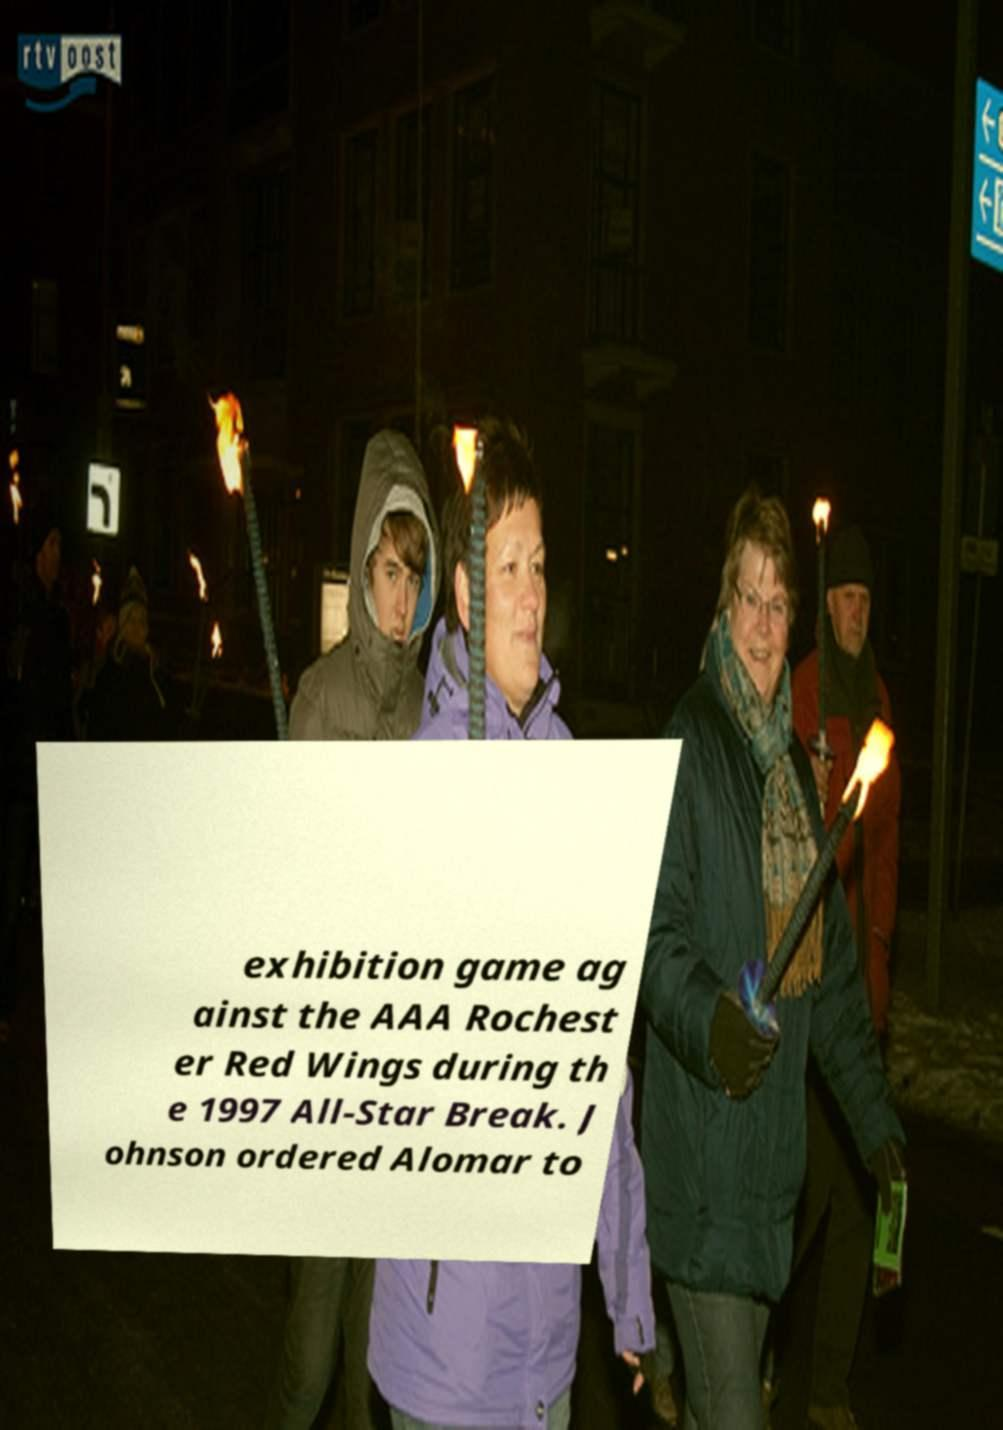Please read and relay the text visible in this image. What does it say? exhibition game ag ainst the AAA Rochest er Red Wings during th e 1997 All-Star Break. J ohnson ordered Alomar to 